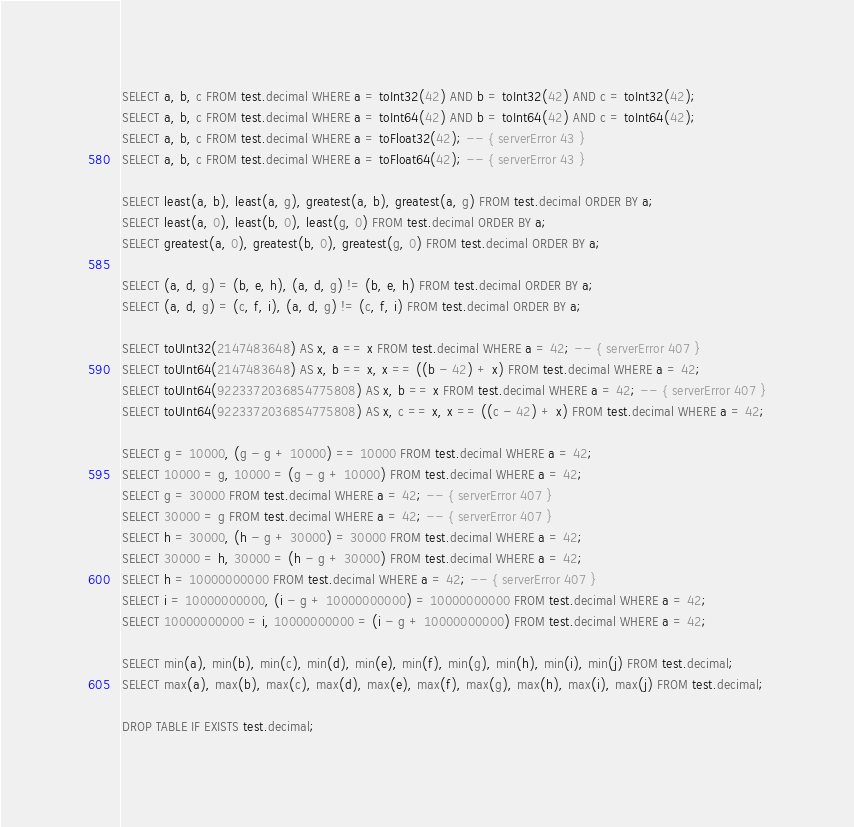Convert code to text. <code><loc_0><loc_0><loc_500><loc_500><_SQL_>SELECT a, b, c FROM test.decimal WHERE a = toInt32(42) AND b = toInt32(42) AND c = toInt32(42);
SELECT a, b, c FROM test.decimal WHERE a = toInt64(42) AND b = toInt64(42) AND c = toInt64(42);
SELECT a, b, c FROM test.decimal WHERE a = toFloat32(42); -- { serverError 43 }
SELECT a, b, c FROM test.decimal WHERE a = toFloat64(42); -- { serverError 43 }

SELECT least(a, b), least(a, g), greatest(a, b), greatest(a, g) FROM test.decimal ORDER BY a;
SELECT least(a, 0), least(b, 0), least(g, 0) FROM test.decimal ORDER BY a;
SELECT greatest(a, 0), greatest(b, 0), greatest(g, 0) FROM test.decimal ORDER BY a;

SELECT (a, d, g) = (b, e, h), (a, d, g) != (b, e, h) FROM test.decimal ORDER BY a;
SELECT (a, d, g) = (c, f, i), (a, d, g) != (c, f, i) FROM test.decimal ORDER BY a;

SELECT toUInt32(2147483648) AS x, a == x FROM test.decimal WHERE a = 42; -- { serverError 407 }
SELECT toUInt64(2147483648) AS x, b == x, x == ((b - 42) + x) FROM test.decimal WHERE a = 42;
SELECT toUInt64(9223372036854775808) AS x, b == x FROM test.decimal WHERE a = 42; -- { serverError 407 }
SELECT toUInt64(9223372036854775808) AS x, c == x, x == ((c - 42) + x) FROM test.decimal WHERE a = 42;

SELECT g = 10000, (g - g + 10000) == 10000 FROM test.decimal WHERE a = 42;
SELECT 10000 = g, 10000 = (g - g + 10000) FROM test.decimal WHERE a = 42;
SELECT g = 30000 FROM test.decimal WHERE a = 42; -- { serverError 407 }
SELECT 30000 = g FROM test.decimal WHERE a = 42; -- { serverError 407 }
SELECT h = 30000, (h - g + 30000) = 30000 FROM test.decimal WHERE a = 42;
SELECT 30000 = h, 30000 = (h - g + 30000) FROM test.decimal WHERE a = 42;
SELECT h = 10000000000 FROM test.decimal WHERE a = 42; -- { serverError 407 }
SELECT i = 10000000000, (i - g + 10000000000) = 10000000000 FROM test.decimal WHERE a = 42;
SELECT 10000000000 = i, 10000000000 = (i - g + 10000000000) FROM test.decimal WHERE a = 42;

SELECT min(a), min(b), min(c), min(d), min(e), min(f), min(g), min(h), min(i), min(j) FROM test.decimal;
SELECT max(a), max(b), max(c), max(d), max(e), max(f), max(g), max(h), max(i), max(j) FROM test.decimal;

DROP TABLE IF EXISTS test.decimal;
</code> 